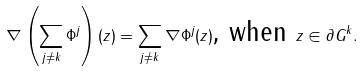<formula> <loc_0><loc_0><loc_500><loc_500>\nabla \left ( \sum _ { j \ne k } \Phi ^ { j } \right ) ( z ) = \sum _ { j \ne k } \nabla \Phi ^ { j } ( z ) \text {, when } z \in \partial G ^ { k } .</formula> 